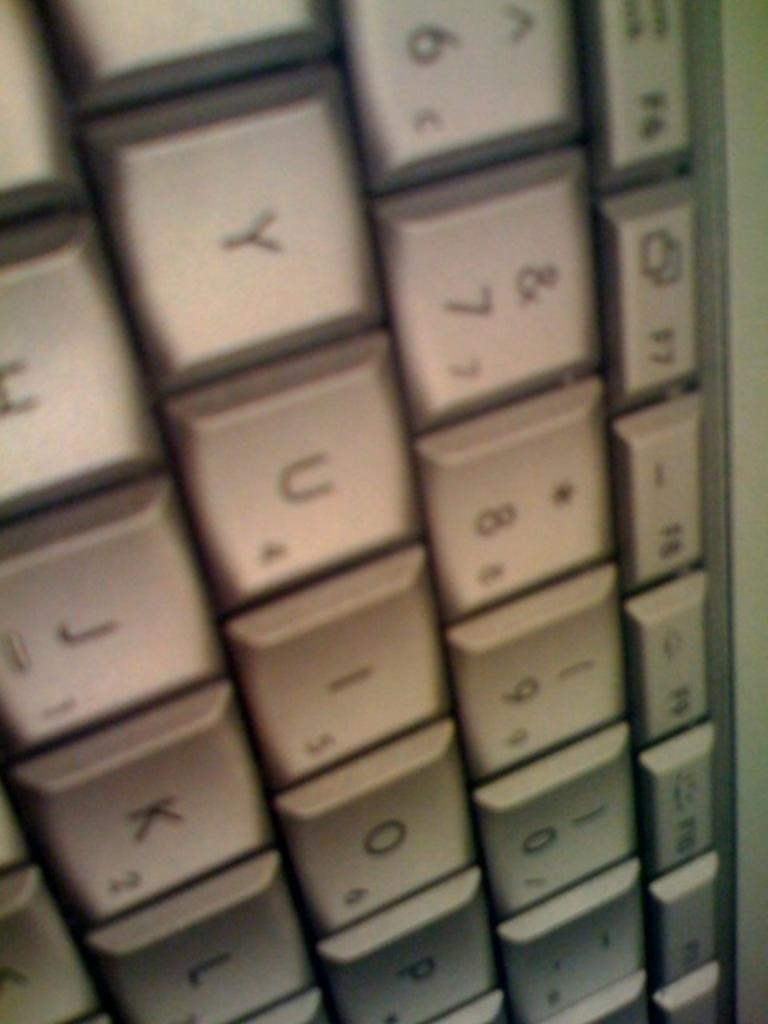<image>
Relay a brief, clear account of the picture shown. A section of a computer keyboard showing several letters and numbers 6 through 9 as well as 0. 